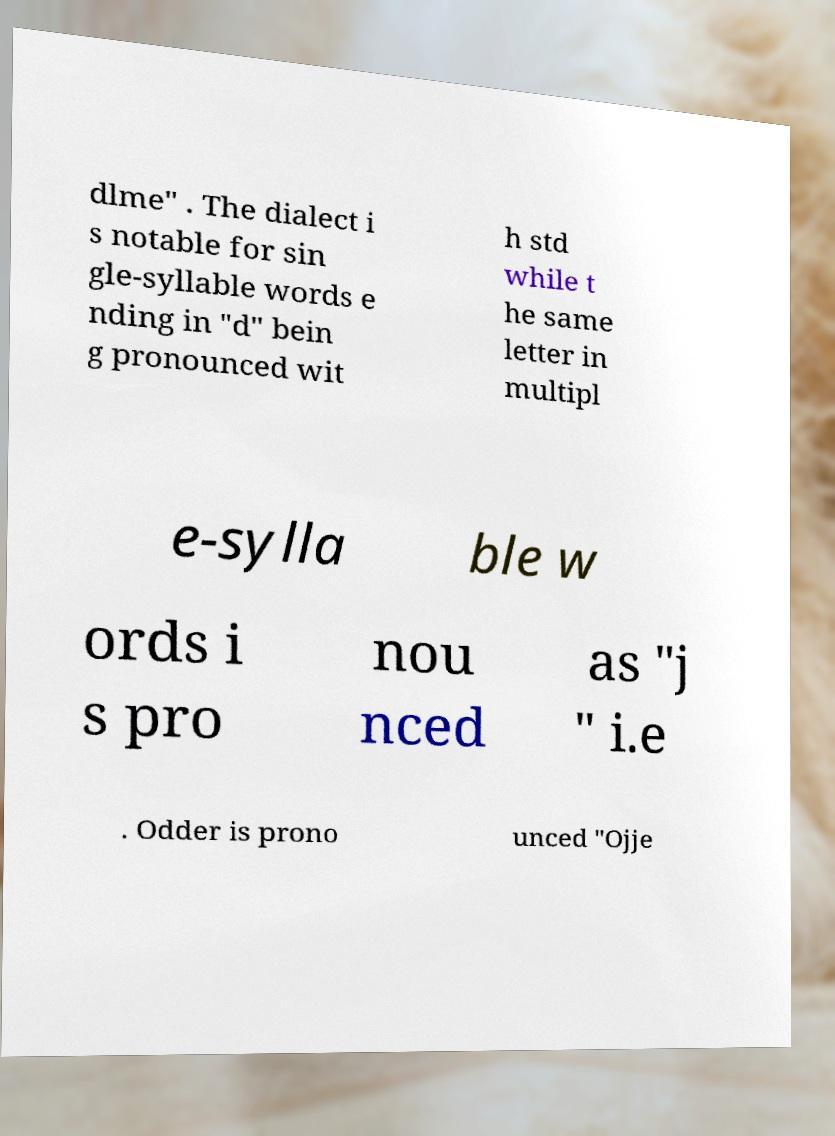Please read and relay the text visible in this image. What does it say? dlme" . The dialect i s notable for sin gle-syllable words e nding in "d" bein g pronounced wit h std while t he same letter in multipl e-sylla ble w ords i s pro nou nced as "j " i.e . Odder is prono unced "Ojje 